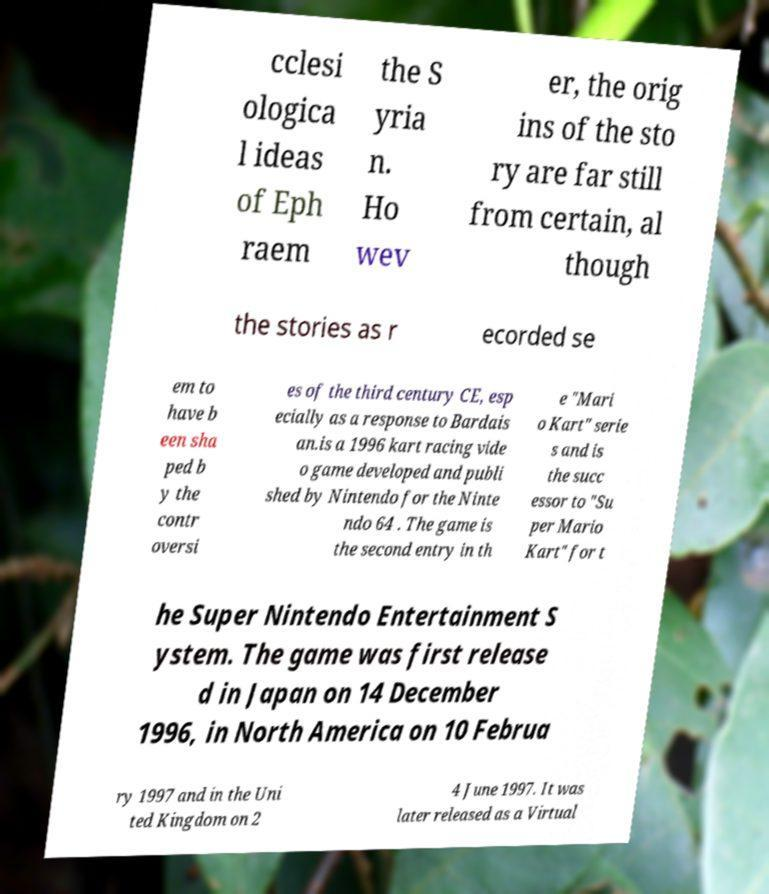For documentation purposes, I need the text within this image transcribed. Could you provide that? cclesi ologica l ideas of Eph raem the S yria n. Ho wev er, the orig ins of the sto ry are far still from certain, al though the stories as r ecorded se em to have b een sha ped b y the contr oversi es of the third century CE, esp ecially as a response to Bardais an.is a 1996 kart racing vide o game developed and publi shed by Nintendo for the Ninte ndo 64 . The game is the second entry in th e "Mari o Kart" serie s and is the succ essor to "Su per Mario Kart" for t he Super Nintendo Entertainment S ystem. The game was first release d in Japan on 14 December 1996, in North America on 10 Februa ry 1997 and in the Uni ted Kingdom on 2 4 June 1997. It was later released as a Virtual 